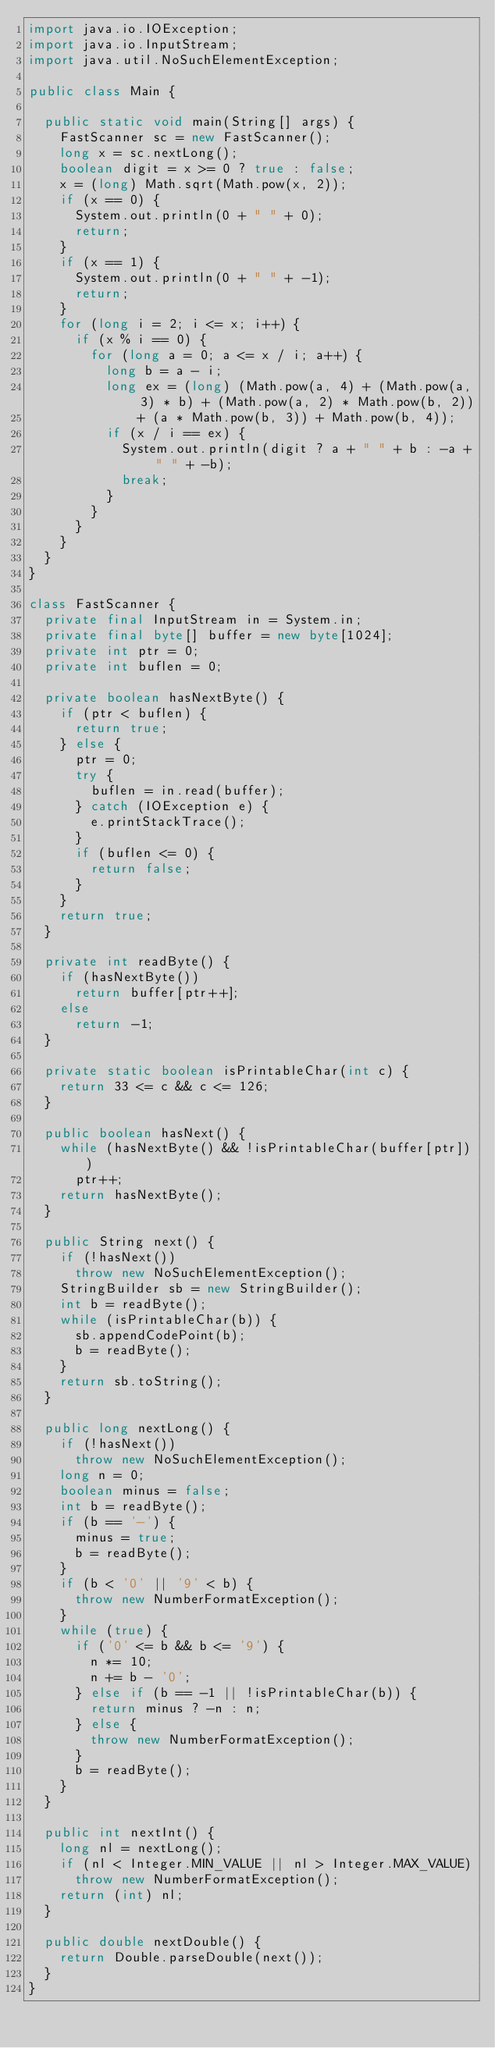Convert code to text. <code><loc_0><loc_0><loc_500><loc_500><_Java_>import java.io.IOException;
import java.io.InputStream;
import java.util.NoSuchElementException;

public class Main {

  public static void main(String[] args) {
    FastScanner sc = new FastScanner();
    long x = sc.nextLong();
    boolean digit = x >= 0 ? true : false;
    x = (long) Math.sqrt(Math.pow(x, 2));
    if (x == 0) {
      System.out.println(0 + " " + 0);
      return;
    }
    if (x == 1) {
      System.out.println(0 + " " + -1);
      return;
    }
    for (long i = 2; i <= x; i++) {
      if (x % i == 0) {
        for (long a = 0; a <= x / i; a++) {
          long b = a - i;
          long ex = (long) (Math.pow(a, 4) + (Math.pow(a, 3) * b) + (Math.pow(a, 2) * Math.pow(b, 2))
              + (a * Math.pow(b, 3)) + Math.pow(b, 4));
          if (x / i == ex) {
            System.out.println(digit ? a + " " + b : -a + " " + -b);
            break;
          }
        }
      }
    }
  }
}

class FastScanner {
  private final InputStream in = System.in;
  private final byte[] buffer = new byte[1024];
  private int ptr = 0;
  private int buflen = 0;

  private boolean hasNextByte() {
    if (ptr < buflen) {
      return true;
    } else {
      ptr = 0;
      try {
        buflen = in.read(buffer);
      } catch (IOException e) {
        e.printStackTrace();
      }
      if (buflen <= 0) {
        return false;
      }
    }
    return true;
  }

  private int readByte() {
    if (hasNextByte())
      return buffer[ptr++];
    else
      return -1;
  }

  private static boolean isPrintableChar(int c) {
    return 33 <= c && c <= 126;
  }

  public boolean hasNext() {
    while (hasNextByte() && !isPrintableChar(buffer[ptr]))
      ptr++;
    return hasNextByte();
  }

  public String next() {
    if (!hasNext())
      throw new NoSuchElementException();
    StringBuilder sb = new StringBuilder();
    int b = readByte();
    while (isPrintableChar(b)) {
      sb.appendCodePoint(b);
      b = readByte();
    }
    return sb.toString();
  }

  public long nextLong() {
    if (!hasNext())
      throw new NoSuchElementException();
    long n = 0;
    boolean minus = false;
    int b = readByte();
    if (b == '-') {
      minus = true;
      b = readByte();
    }
    if (b < '0' || '9' < b) {
      throw new NumberFormatException();
    }
    while (true) {
      if ('0' <= b && b <= '9') {
        n *= 10;
        n += b - '0';
      } else if (b == -1 || !isPrintableChar(b)) {
        return minus ? -n : n;
      } else {
        throw new NumberFormatException();
      }
      b = readByte();
    }
  }

  public int nextInt() {
    long nl = nextLong();
    if (nl < Integer.MIN_VALUE || nl > Integer.MAX_VALUE)
      throw new NumberFormatException();
    return (int) nl;
  }

  public double nextDouble() {
    return Double.parseDouble(next());
  }
}</code> 